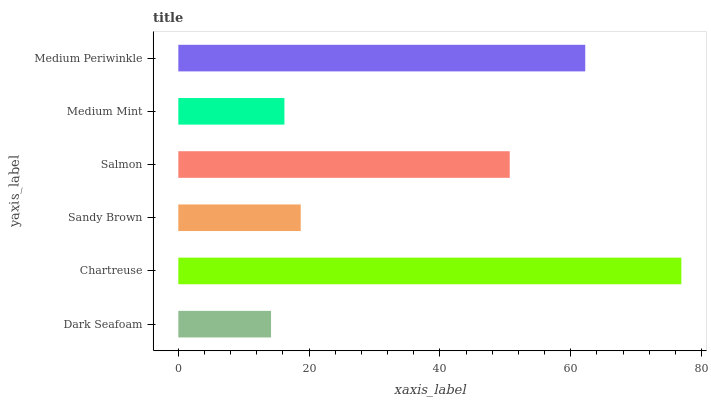Is Dark Seafoam the minimum?
Answer yes or no. Yes. Is Chartreuse the maximum?
Answer yes or no. Yes. Is Sandy Brown the minimum?
Answer yes or no. No. Is Sandy Brown the maximum?
Answer yes or no. No. Is Chartreuse greater than Sandy Brown?
Answer yes or no. Yes. Is Sandy Brown less than Chartreuse?
Answer yes or no. Yes. Is Sandy Brown greater than Chartreuse?
Answer yes or no. No. Is Chartreuse less than Sandy Brown?
Answer yes or no. No. Is Salmon the high median?
Answer yes or no. Yes. Is Sandy Brown the low median?
Answer yes or no. Yes. Is Sandy Brown the high median?
Answer yes or no. No. Is Medium Periwinkle the low median?
Answer yes or no. No. 